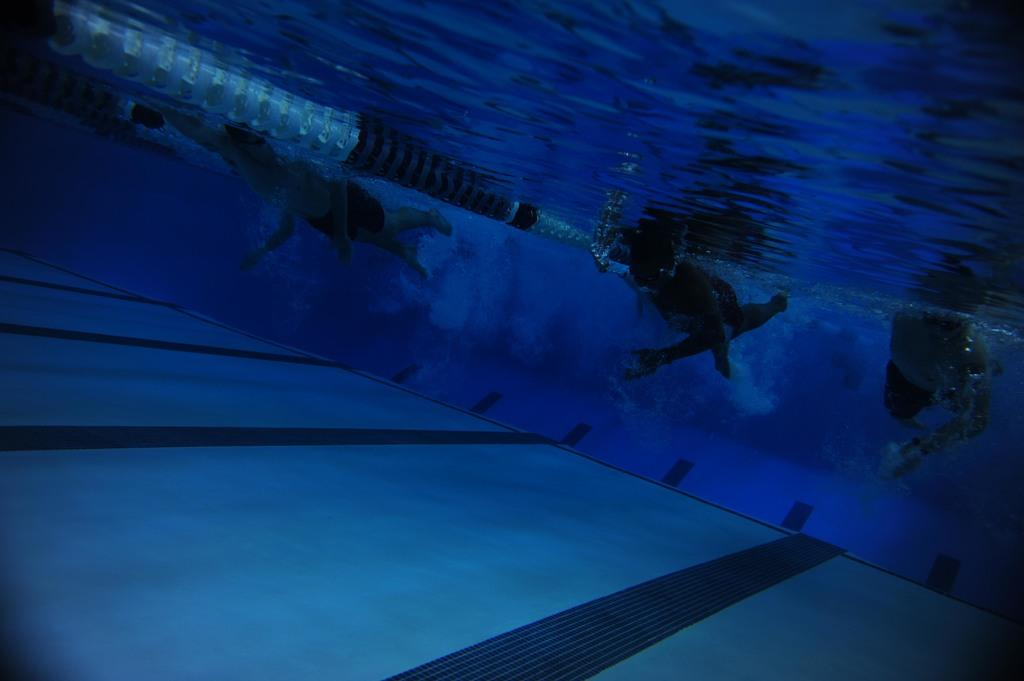What type of location is depicted in the image? The image shows an inside view of a swimming pool. Are there any people present in the image? Yes, there are people in the swimming pool. What is the main feature of the swimming pool? The swimming pool has a floor. What is the primary element in the swimming pool? There is water in the swimming pool. What type of mask is being worn by the people in the swimming pool? There is no mention of masks in the image, as the focus is on the swimming pool and the people inside it. 